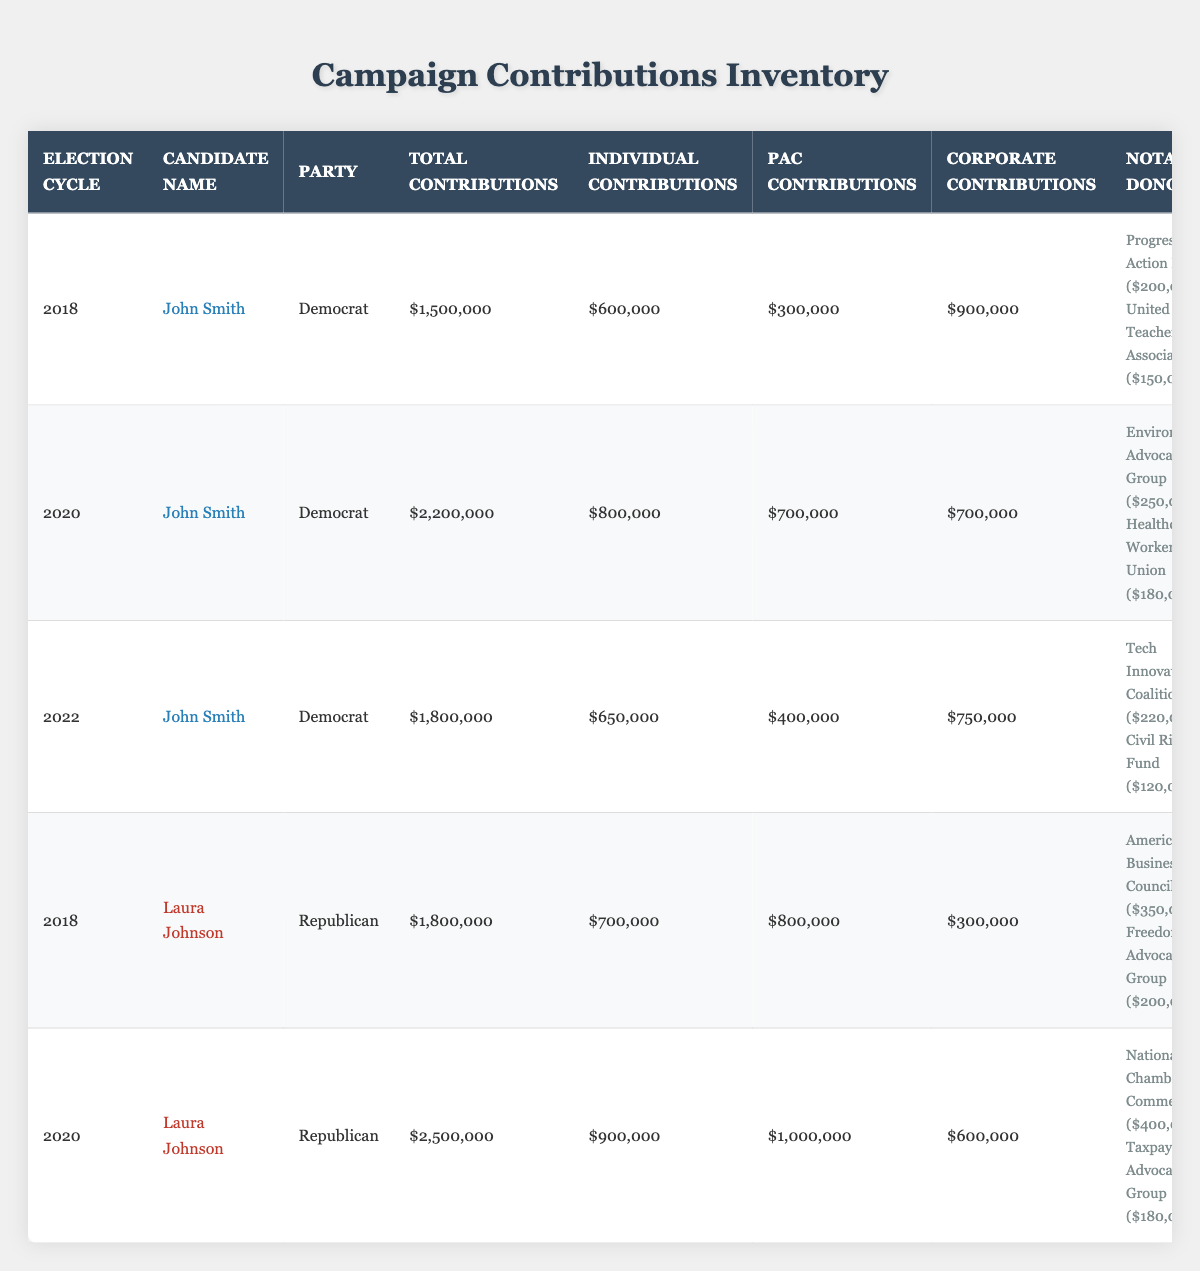What was the total contributions for John Smith in the 2020 election cycle? The total contributions for John Smith in the 2020 election cycle are listed in the table as $2,200,000.
Answer: $2,200,000 Which candidate received more corporate contributions in 2018: John Smith or Laura Johnson? In the table, John Smith received $900,000 in corporate contributions, while Laura Johnson received $300,000. Since $900,000 is greater than $300,000, John Smith received more corporate contributions in 2018.
Answer: John Smith What is the total amount of individual contributions received by Laura Johnson across both election cycles? In the 2018 election cycle, Laura Johnson received $700,000 in individual contributions, and in 2020, she received $900,000. Therefore, the total is $700,000 + $900,000 = $1,600,000.
Answer: $1,600,000 Did John Smith receive more in total contributions during the 2022 election cycle compared to the 2018 election cycle? In 2022, John Smith received $1,800,000 total contributions, while in 2018 he received $1,500,000. Since $1,800,000 is greater than $1,500,000, it is true that he received more in 2022 compared to 2018.
Answer: Yes What is the average total contributions for the Democratic candidates across all election cycles listed? The total contributions for John Smith in 2018, 2020, and 2022 are $1,500,000, $2,200,000, and $1,800,000 respectively. Summing these gives $1,500,000 + $2,200,000 + $1,800,000 = $5,500,000. Since there are 3 contributions, the average is $5,500,000 / 3 = $1,833,333.
Answer: $1,833,333 